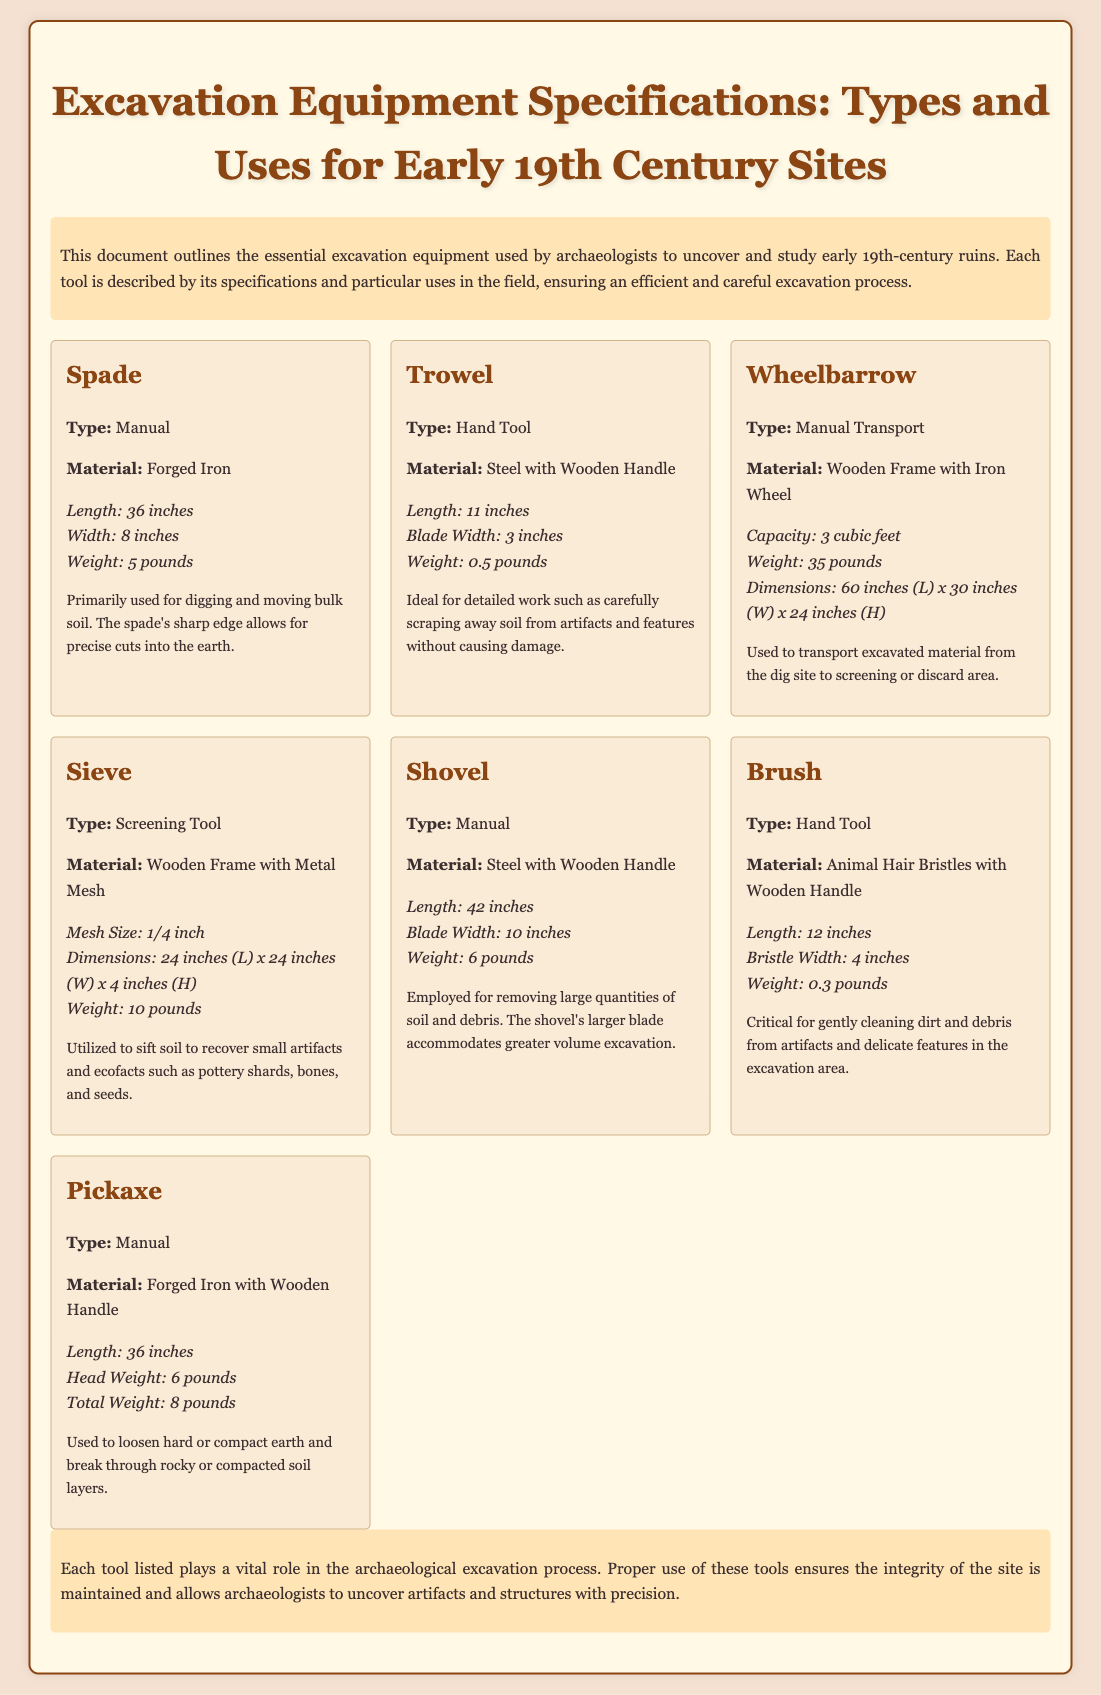What is the length of a spade? The length of a spade is specified in the document.
Answer: 36 inches What material is a trowel made of? The document specifies the material used for a trowel.
Answer: Steel with Wooden Handle What is the weight of the wheelbarrow? The weight of the wheelbarrow is given in the document.
Answer: 35 pounds How is the sieve used in excavation? The document describes the purpose of the sieve in excavation processes.
Answer: To sift soil to recover small artifacts Which tool is primarily used for moving bulk soil? The document identifies which tool serves this purpose.
Answer: Spade What is the mesh size of the sieve? The document includes specifications for the sieve, including its mesh size.
Answer: 1/4 inch How much does the pickaxe weigh? The document lists the total weight of the pickaxe in specifications.
Answer: 8 pounds What type of tool is a brush categorized as? The document categorizes tools and specifies the type of the brush.
Answer: Hand Tool How many cubic feet can the wheelbarrow transport? The capacity of the wheelbarrow is stated in the document.
Answer: 3 cubic feet 